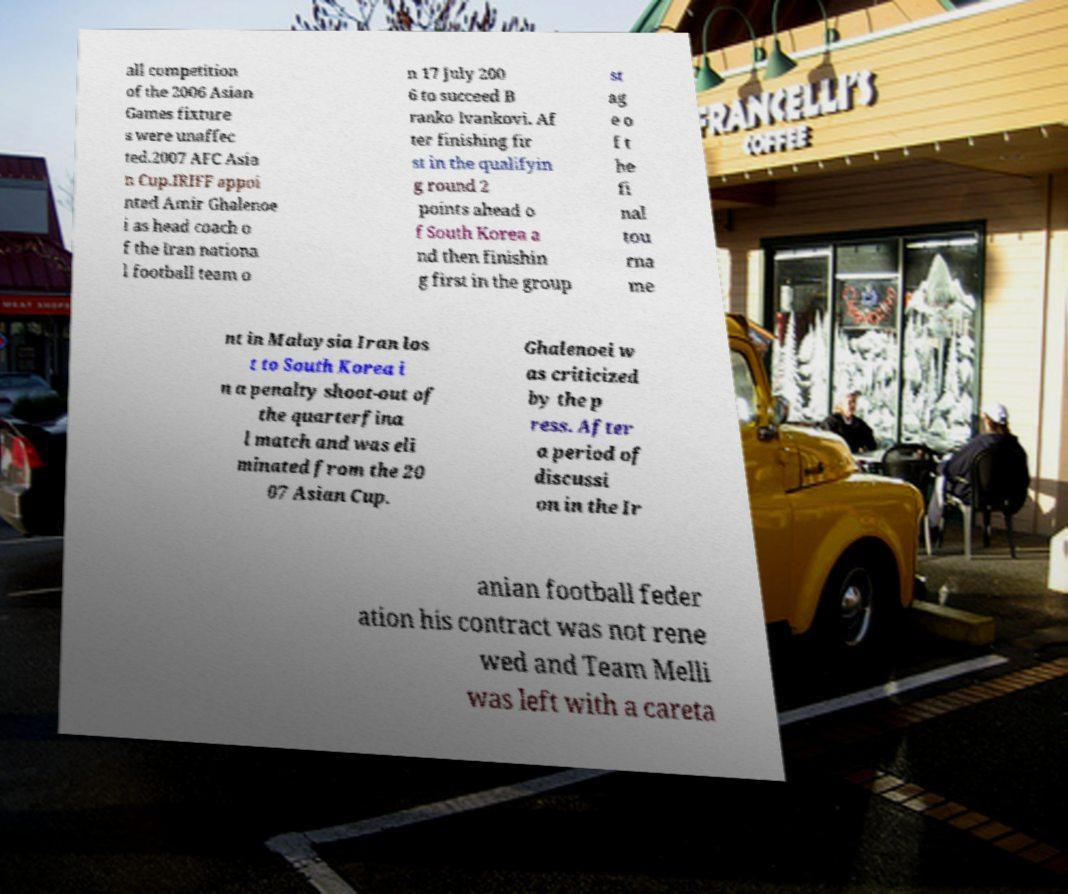Please identify and transcribe the text found in this image. all competition of the 2006 Asian Games fixture s were unaffec ted.2007 AFC Asia n Cup.IRIFF appoi nted Amir Ghalenoe i as head coach o f the Iran nationa l football team o n 17 July 200 6 to succeed B ranko Ivankovi. Af ter finishing fir st in the qualifyin g round 2 points ahead o f South Korea a nd then finishin g first in the group st ag e o f t he fi nal tou rna me nt in Malaysia Iran los t to South Korea i n a penalty shoot-out of the quarterfina l match and was eli minated from the 20 07 Asian Cup. Ghalenoei w as criticized by the p ress. After a period of discussi on in the Ir anian football feder ation his contract was not rene wed and Team Melli was left with a careta 